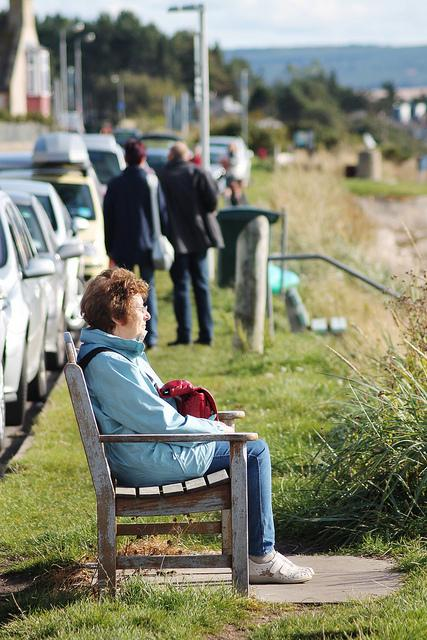How are her shoes tightened? Please explain your reasoning. velcro. The straps on her shoes are velcro. 